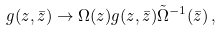Convert formula to latex. <formula><loc_0><loc_0><loc_500><loc_500>g ( z , \bar { z } ) \to \Omega ( z ) g ( z , \bar { z } ) \tilde { \Omega } ^ { - 1 } ( \bar { z } ) \, ,</formula> 